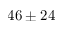Convert formula to latex. <formula><loc_0><loc_0><loc_500><loc_500>4 6 \pm 2 4</formula> 